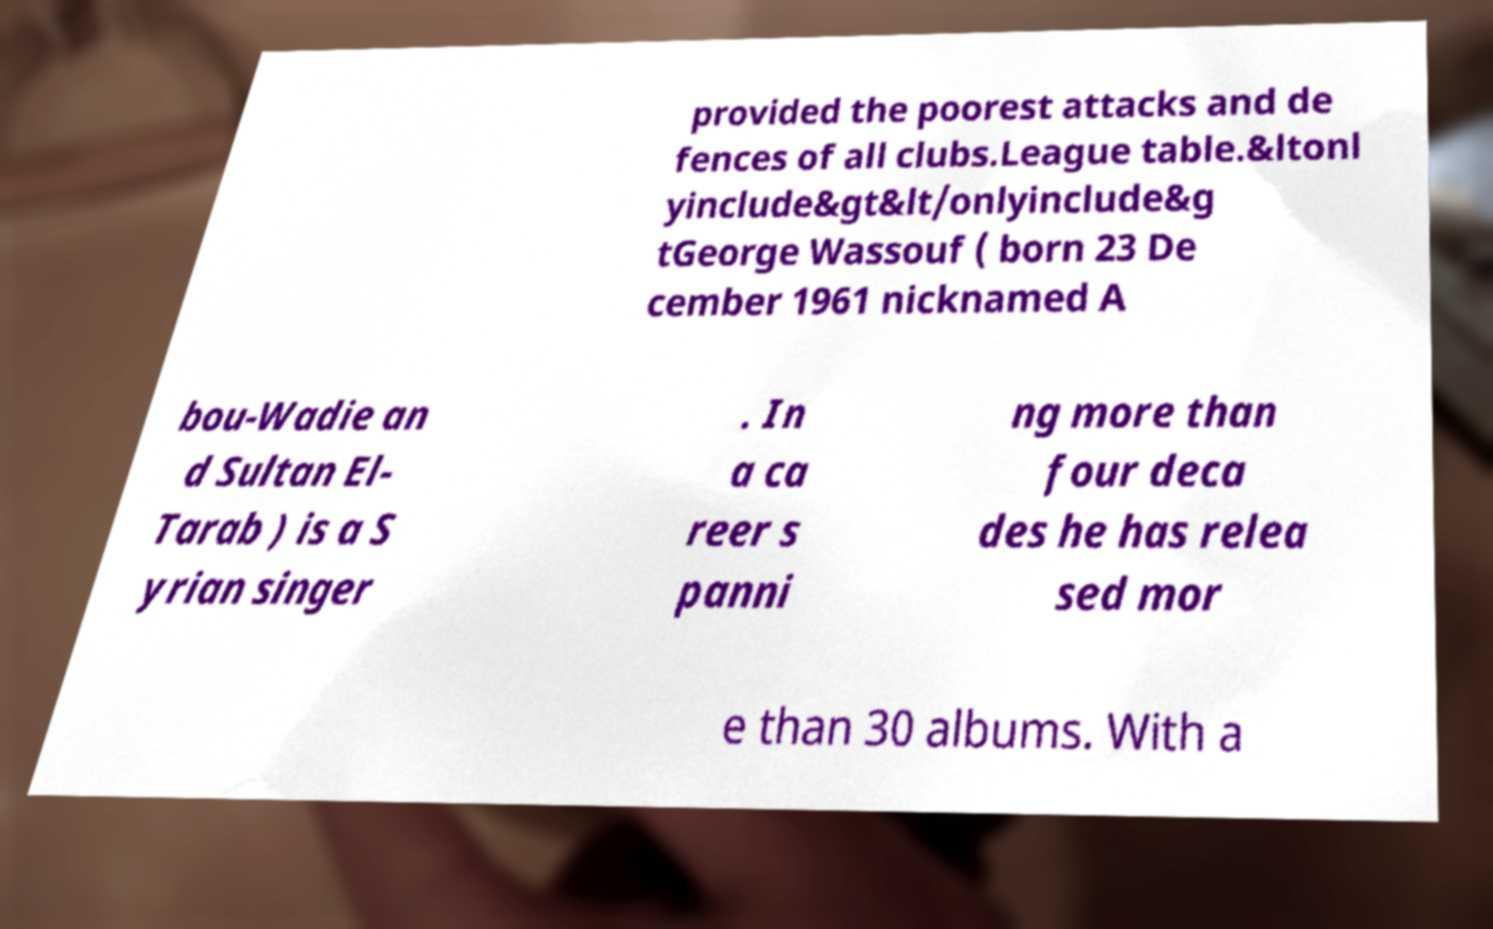Could you extract and type out the text from this image? provided the poorest attacks and de fences of all clubs.League table.&ltonl yinclude&gt&lt/onlyinclude&g tGeorge Wassouf ( born 23 De cember 1961 nicknamed A bou-Wadie an d Sultan El- Tarab ) is a S yrian singer . In a ca reer s panni ng more than four deca des he has relea sed mor e than 30 albums. With a 